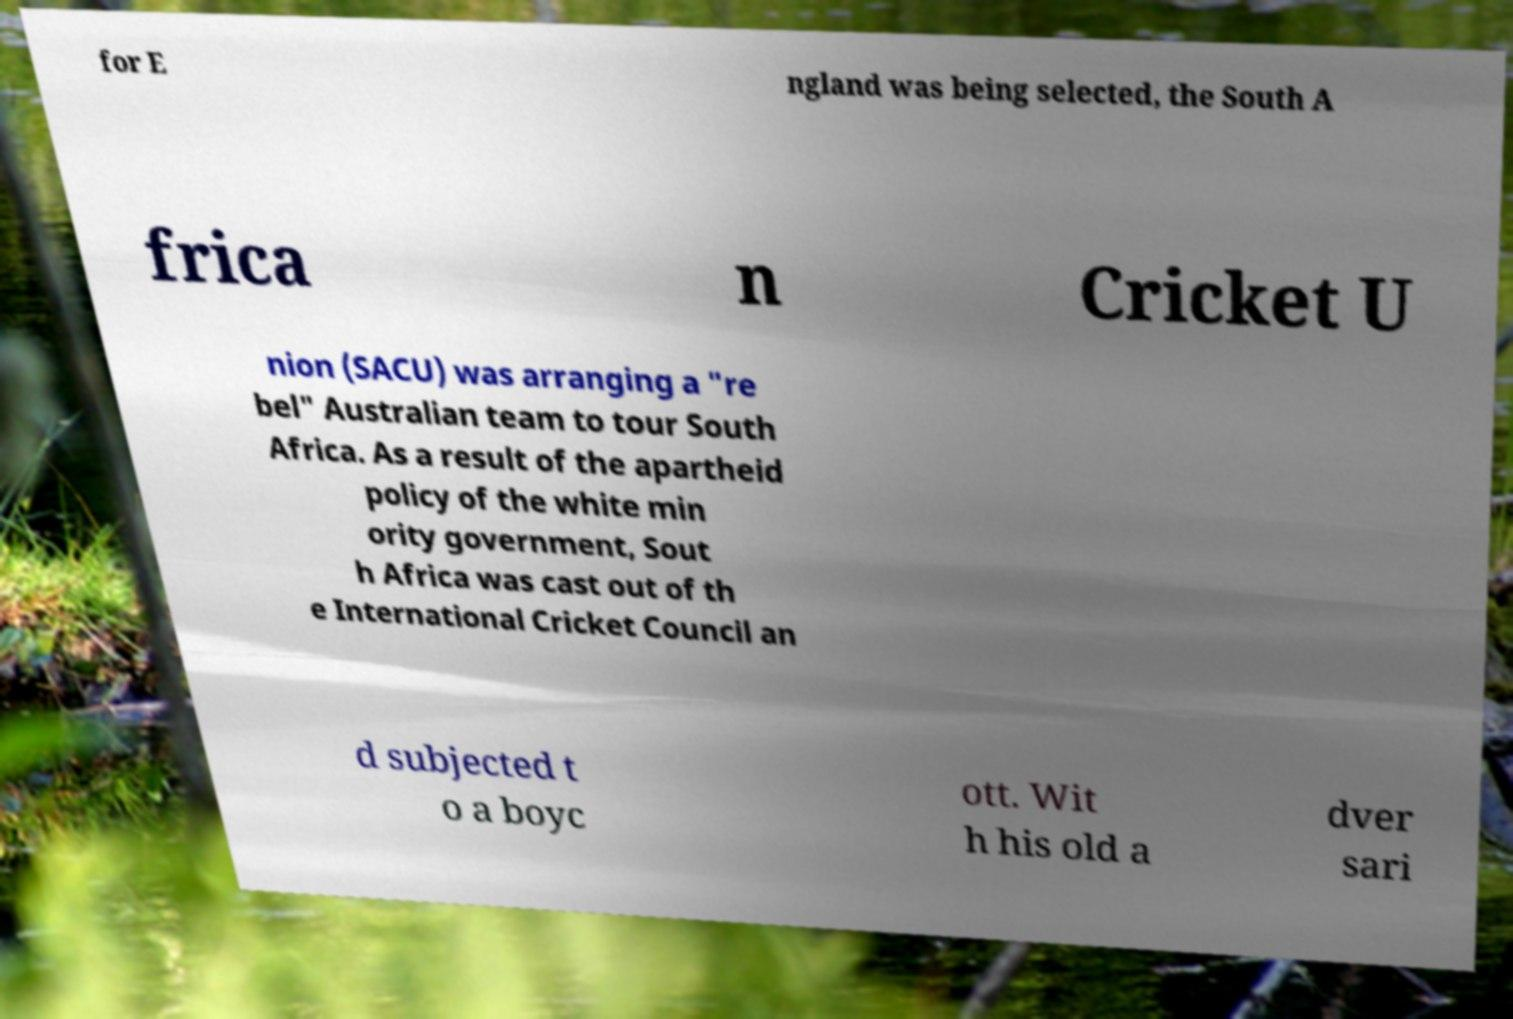Please identify and transcribe the text found in this image. for E ngland was being selected, the South A frica n Cricket U nion (SACU) was arranging a "re bel" Australian team to tour South Africa. As a result of the apartheid policy of the white min ority government, Sout h Africa was cast out of th e International Cricket Council an d subjected t o a boyc ott. Wit h his old a dver sari 